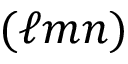Convert formula to latex. <formula><loc_0><loc_0><loc_500><loc_500>( \ell m n )</formula> 